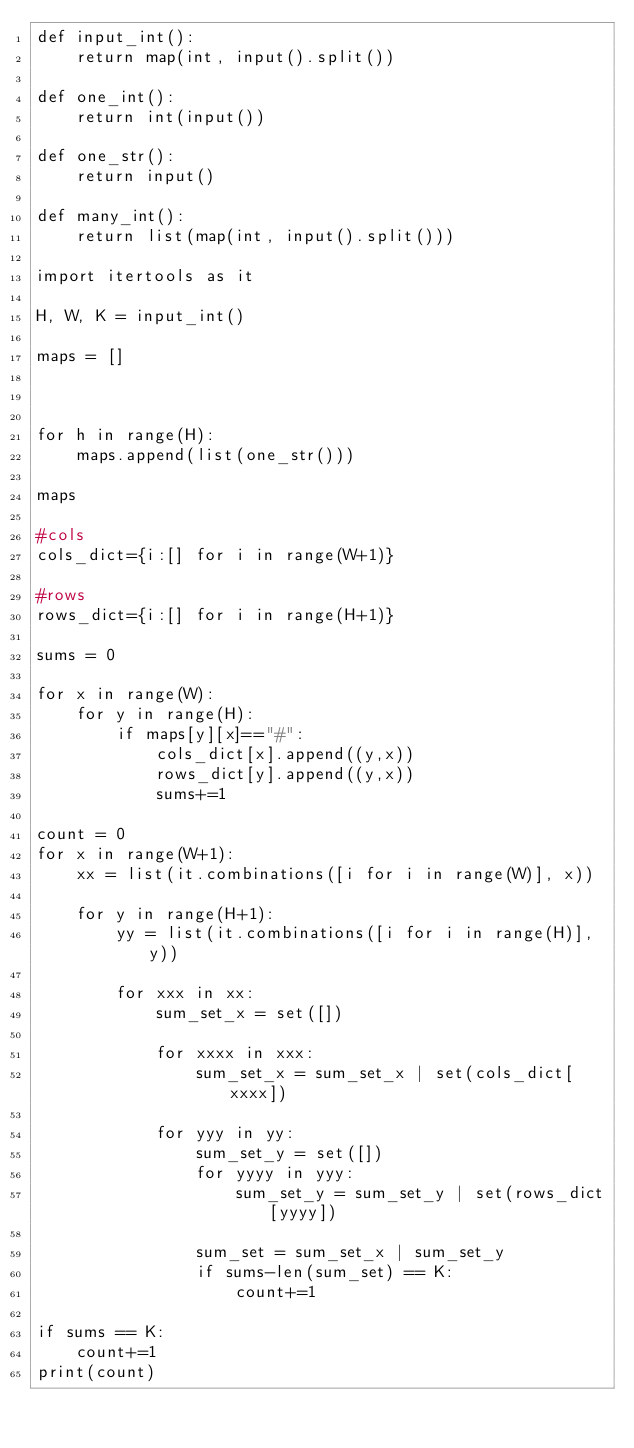Convert code to text. <code><loc_0><loc_0><loc_500><loc_500><_Python_>def input_int():
    return map(int, input().split())

def one_int():
    return int(input())

def one_str():
    return input()

def many_int():
    return list(map(int, input().split()))

import itertools as it

H, W, K = input_int()

maps = []



for h in range(H):
    maps.append(list(one_str()))

maps

#cols
cols_dict={i:[] for i in range(W+1)}

#rows
rows_dict={i:[] for i in range(H+1)}

sums = 0

for x in range(W):
    for y in range(H):
        if maps[y][x]=="#":
            cols_dict[x].append((y,x))
            rows_dict[y].append((y,x))
            sums+=1

count = 0
for x in range(W+1):
    xx = list(it.combinations([i for i in range(W)], x))
    
    for y in range(H+1):
        yy = list(it.combinations([i for i in range(H)], y))

        for xxx in xx:
            sum_set_x = set([])

            for xxxx in xxx:
                sum_set_x = sum_set_x | set(cols_dict[xxxx])
        
            for yyy in yy:
                sum_set_y = set([])
                for yyyy in yyy:
                    sum_set_y = sum_set_y | set(rows_dict[yyyy])

                sum_set = sum_set_x | sum_set_y
                if sums-len(sum_set) == K:
                    count+=1

if sums == K:
    count+=1
print(count)</code> 